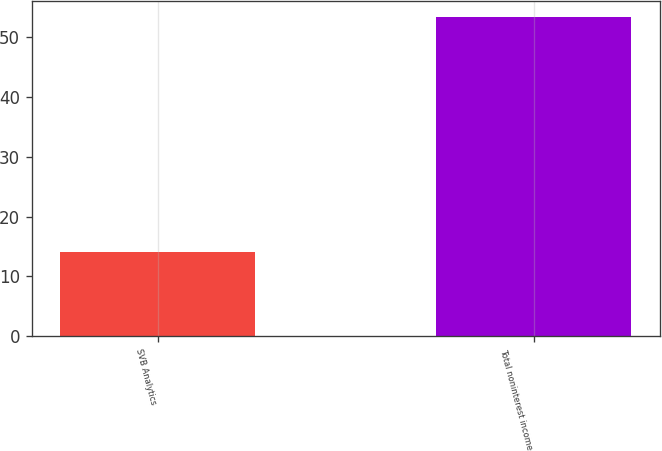<chart> <loc_0><loc_0><loc_500><loc_500><bar_chart><fcel>SVB Analytics<fcel>Total noninterest income<nl><fcel>14.1<fcel>53.4<nl></chart> 